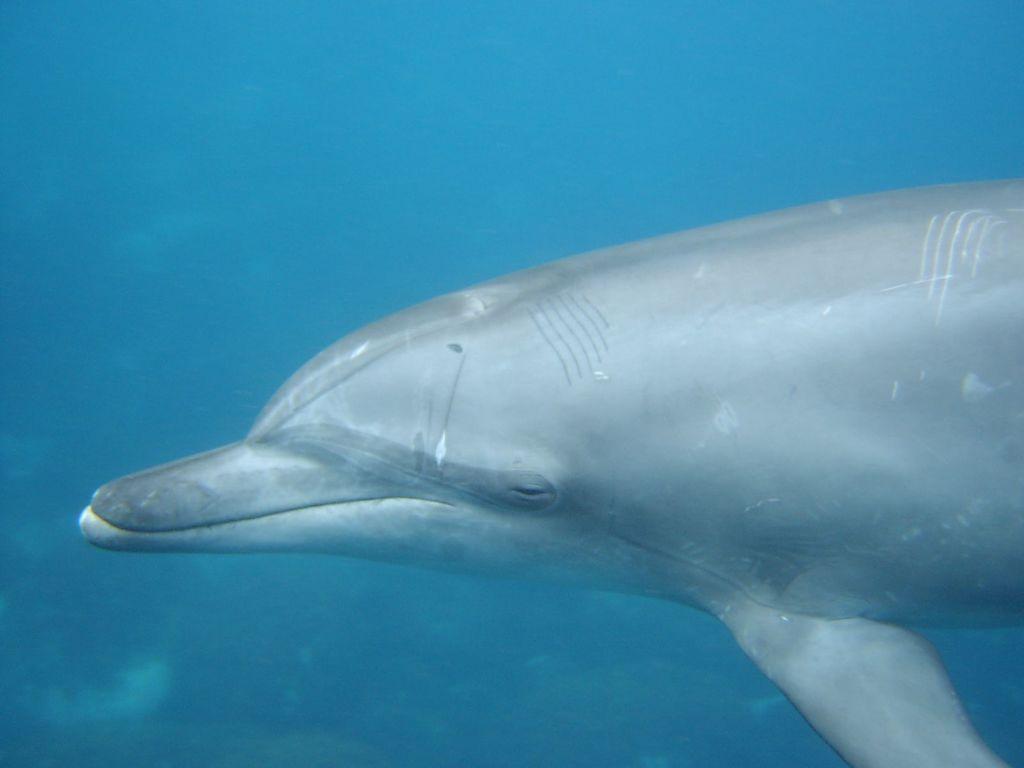How would you summarize this image in a sentence or two? In this image I can see an aquatic animal which is in grey color. In the back I can see the blue water. 